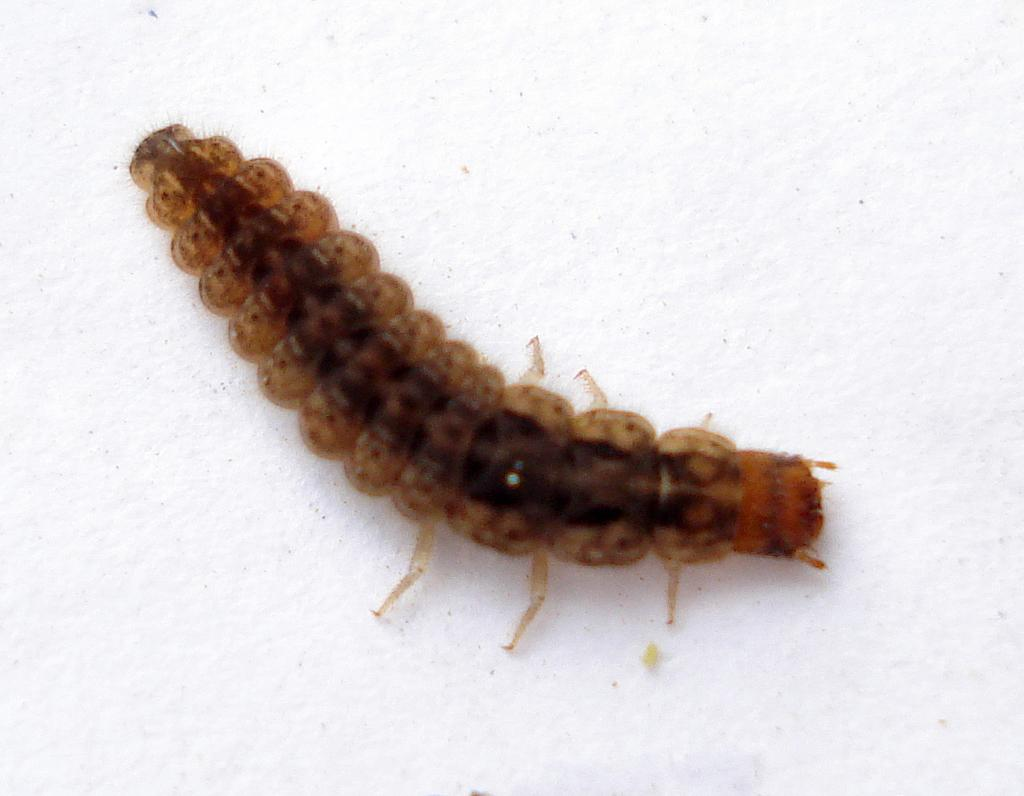What is the main subject of the image? The main subject of the image is a worm. Where is the worm located in the image? The worm is in the center of the image. What is the worm's position in relation to its surroundings? The worm is on the surface in the image. What type of shoes can be seen near the worm in the image? There are no shoes present in the image; it only features a worm on the surface. 